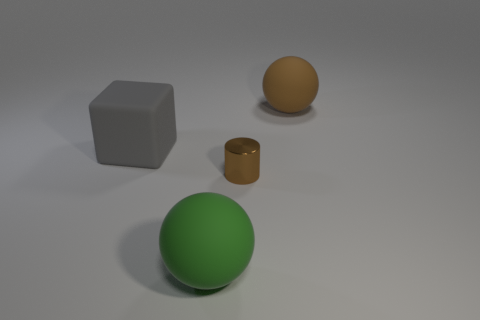Is there another rubber object that has the same shape as the gray matte object?
Your answer should be compact. No. Do the large brown sphere and the ball in front of the shiny cylinder have the same material?
Provide a short and direct response. Yes. Is there a small matte cube of the same color as the tiny shiny cylinder?
Offer a terse response. No. How many other objects are there of the same material as the large brown object?
Offer a terse response. 2. Do the small metallic object and the matte ball that is right of the brown shiny object have the same color?
Keep it short and to the point. Yes. Are there more rubber objects to the right of the cylinder than large gray shiny balls?
Your response must be concise. Yes. How many big blocks are on the right side of the sphere that is on the right side of the large rubber sphere that is in front of the large brown rubber thing?
Your response must be concise. 0. There is a big thing that is behind the gray rubber cube; is it the same shape as the green thing?
Your answer should be very brief. Yes. What is the large ball that is behind the tiny brown cylinder made of?
Your answer should be very brief. Rubber. The thing that is both to the right of the big green rubber ball and in front of the block has what shape?
Ensure brevity in your answer.  Cylinder. 